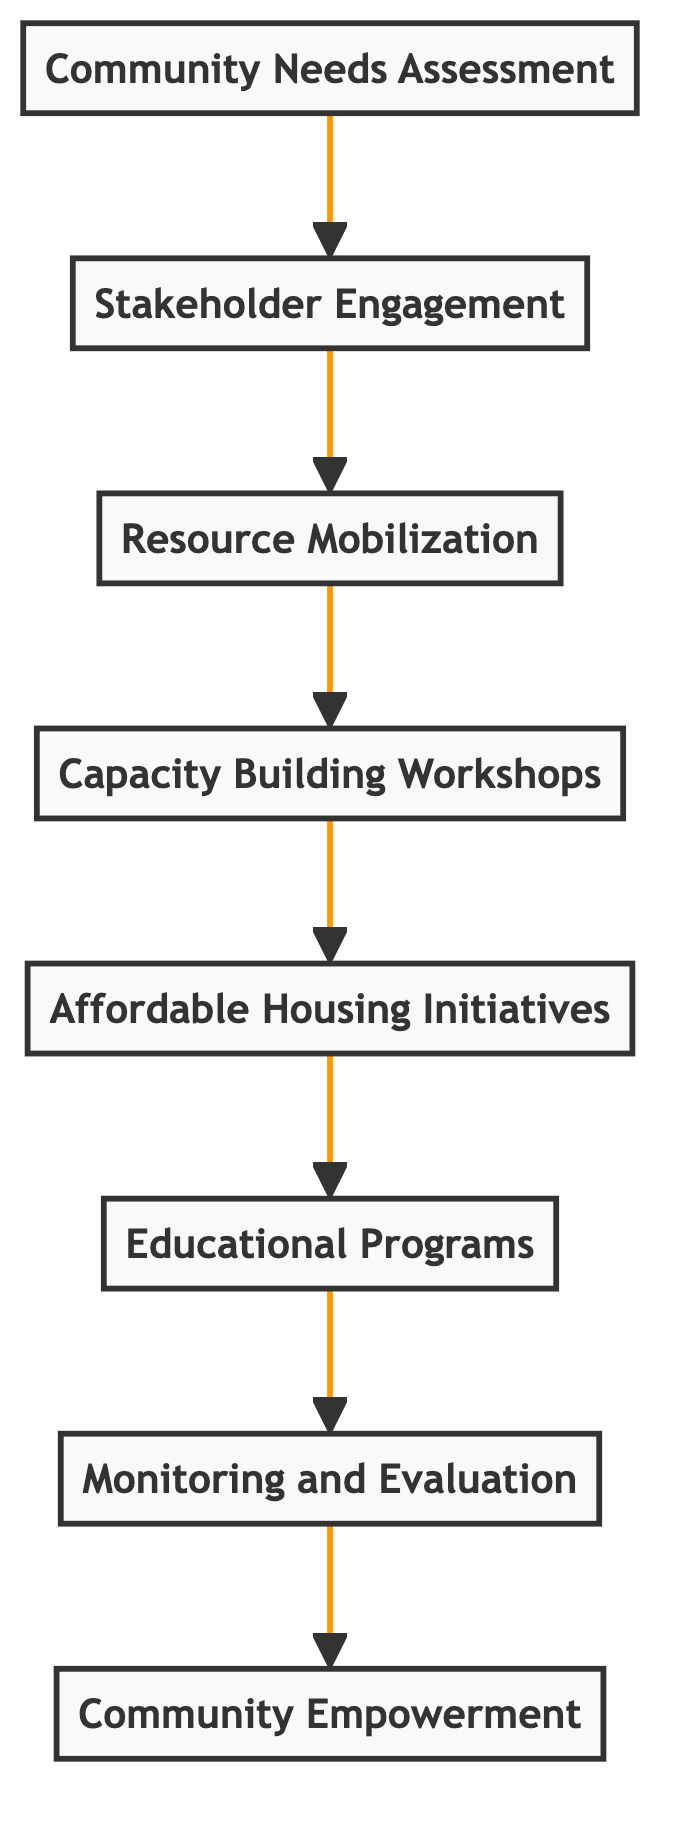What is the final goal of the pathway? The diagram culminates in the last node labeled "Community Empowerment," indicating that this is the ultimate objective of the pathway outlined.
Answer: Community Empowerment How many levels are there in the diagram? By counting each level from "Community Needs Assessment" to "Community Empowerment," there are eight distinct levels represented in the flowchart.
Answer: Eight What action follows "Resource Mobilization"? The diagram shows a direct arrow leading from "Resource Mobilization" to "Capacity Building Workshops," indicating that capacity building follows the gathering of resources.
Answer: Capacity Building Workshops Which node directly precedes "Affordable Housing Initiatives"? The diagram illustrates that "Capacity Building Workshops" is the node directly before "Affordable Housing Initiatives," providing a sequence of actions in the pathway.
Answer: Capacity Building Workshops What is the relationship between "Educational Programs" and "Monitoring and Evaluation"? The diagram indicates that "Educational Programs" leads directly to "Monitoring and Evaluation," establishing a flow where educational initiatives are assessed for their impact.
Answer: Leads directly to What is the first step in the pathway? The first node in the diagram is "Community Needs Assessment," which represents the initial step required to identify community needs in the context of housing and education.
Answer: Community Needs Assessment How does "Stakeholder Engagement" connect to "Resource Mobilization"? The diagram displays a direct connection with an arrow from "Stakeholder Engagement" to "Resource Mobilization," indicating that engagement with stakeholders enables the mobilization of resources.
Answer: Enables the mobilization of resources Which two nodes are connected before “Capacity Building Workshops”? The flowchart outlines a connection from "Stakeholder Engagement" to "Resource Mobilization," and both are prerequisites for "Capacity Building Workshops." Hence, these two nodes are connected before reaching the workshops.
Answer: Stakeholder Engagement and Resource Mobilization What step comes after "Educational Programs"? Examining the arrows in the diagram, it's evident that "Educational Programs" leads into "Monitoring and Evaluation," indicating the next step in the progression.
Answer: Monitoring and Evaluation 